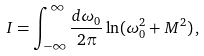<formula> <loc_0><loc_0><loc_500><loc_500>I = \int _ { - \infty } ^ { \infty } \frac { d \omega _ { 0 } } { 2 \pi } \ln ( \omega _ { 0 } ^ { 2 } + M ^ { 2 } ) \, ,</formula> 